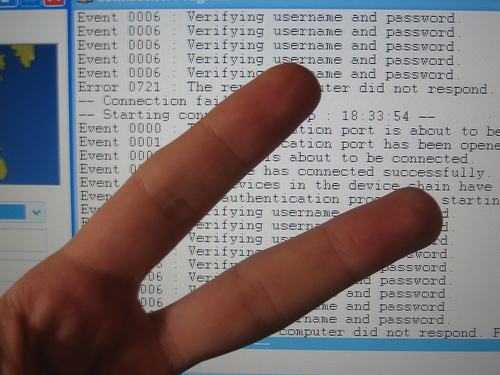<image>
Can you confirm if the finger is above the computer screen? Yes. The finger is positioned above the computer screen in the vertical space, higher up in the scene. 